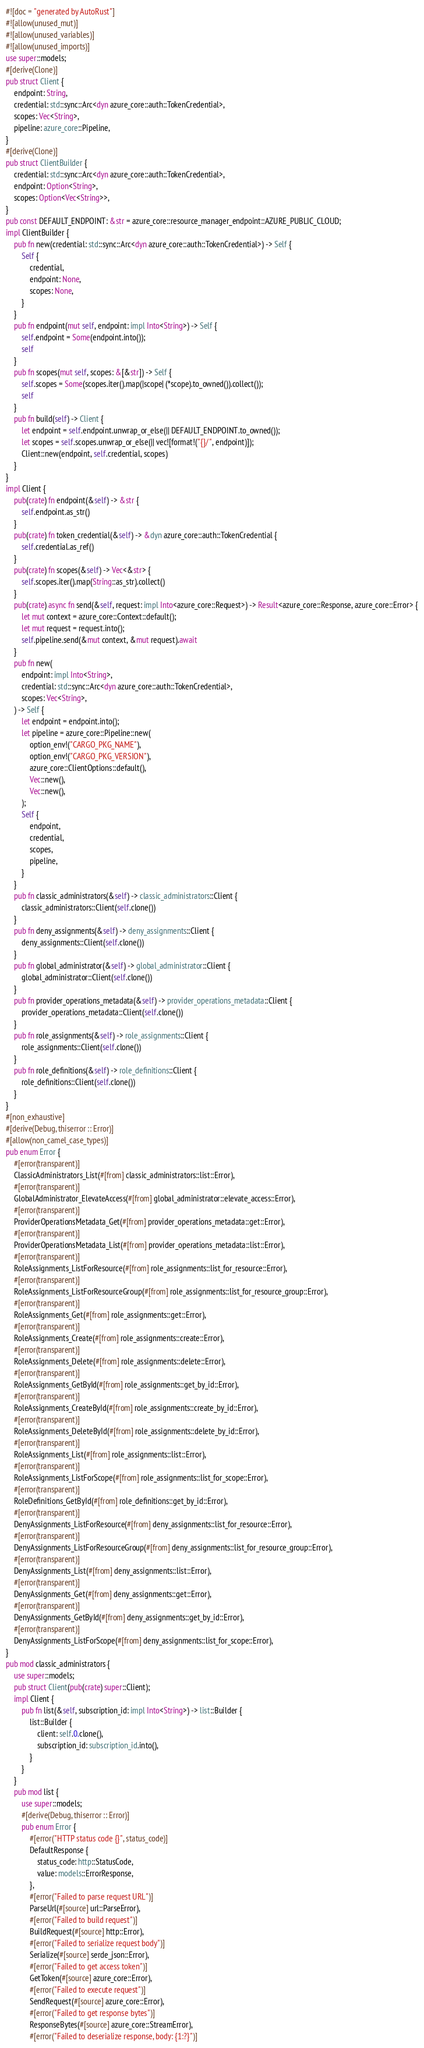<code> <loc_0><loc_0><loc_500><loc_500><_Rust_>#![doc = "generated by AutoRust"]
#![allow(unused_mut)]
#![allow(unused_variables)]
#![allow(unused_imports)]
use super::models;
#[derive(Clone)]
pub struct Client {
    endpoint: String,
    credential: std::sync::Arc<dyn azure_core::auth::TokenCredential>,
    scopes: Vec<String>,
    pipeline: azure_core::Pipeline,
}
#[derive(Clone)]
pub struct ClientBuilder {
    credential: std::sync::Arc<dyn azure_core::auth::TokenCredential>,
    endpoint: Option<String>,
    scopes: Option<Vec<String>>,
}
pub const DEFAULT_ENDPOINT: &str = azure_core::resource_manager_endpoint::AZURE_PUBLIC_CLOUD;
impl ClientBuilder {
    pub fn new(credential: std::sync::Arc<dyn azure_core::auth::TokenCredential>) -> Self {
        Self {
            credential,
            endpoint: None,
            scopes: None,
        }
    }
    pub fn endpoint(mut self, endpoint: impl Into<String>) -> Self {
        self.endpoint = Some(endpoint.into());
        self
    }
    pub fn scopes(mut self, scopes: &[&str]) -> Self {
        self.scopes = Some(scopes.iter().map(|scope| (*scope).to_owned()).collect());
        self
    }
    pub fn build(self) -> Client {
        let endpoint = self.endpoint.unwrap_or_else(|| DEFAULT_ENDPOINT.to_owned());
        let scopes = self.scopes.unwrap_or_else(|| vec![format!("{}/", endpoint)]);
        Client::new(endpoint, self.credential, scopes)
    }
}
impl Client {
    pub(crate) fn endpoint(&self) -> &str {
        self.endpoint.as_str()
    }
    pub(crate) fn token_credential(&self) -> &dyn azure_core::auth::TokenCredential {
        self.credential.as_ref()
    }
    pub(crate) fn scopes(&self) -> Vec<&str> {
        self.scopes.iter().map(String::as_str).collect()
    }
    pub(crate) async fn send(&self, request: impl Into<azure_core::Request>) -> Result<azure_core::Response, azure_core::Error> {
        let mut context = azure_core::Context::default();
        let mut request = request.into();
        self.pipeline.send(&mut context, &mut request).await
    }
    pub fn new(
        endpoint: impl Into<String>,
        credential: std::sync::Arc<dyn azure_core::auth::TokenCredential>,
        scopes: Vec<String>,
    ) -> Self {
        let endpoint = endpoint.into();
        let pipeline = azure_core::Pipeline::new(
            option_env!("CARGO_PKG_NAME"),
            option_env!("CARGO_PKG_VERSION"),
            azure_core::ClientOptions::default(),
            Vec::new(),
            Vec::new(),
        );
        Self {
            endpoint,
            credential,
            scopes,
            pipeline,
        }
    }
    pub fn classic_administrators(&self) -> classic_administrators::Client {
        classic_administrators::Client(self.clone())
    }
    pub fn deny_assignments(&self) -> deny_assignments::Client {
        deny_assignments::Client(self.clone())
    }
    pub fn global_administrator(&self) -> global_administrator::Client {
        global_administrator::Client(self.clone())
    }
    pub fn provider_operations_metadata(&self) -> provider_operations_metadata::Client {
        provider_operations_metadata::Client(self.clone())
    }
    pub fn role_assignments(&self) -> role_assignments::Client {
        role_assignments::Client(self.clone())
    }
    pub fn role_definitions(&self) -> role_definitions::Client {
        role_definitions::Client(self.clone())
    }
}
#[non_exhaustive]
#[derive(Debug, thiserror :: Error)]
#[allow(non_camel_case_types)]
pub enum Error {
    #[error(transparent)]
    ClassicAdministrators_List(#[from] classic_administrators::list::Error),
    #[error(transparent)]
    GlobalAdministrator_ElevateAccess(#[from] global_administrator::elevate_access::Error),
    #[error(transparent)]
    ProviderOperationsMetadata_Get(#[from] provider_operations_metadata::get::Error),
    #[error(transparent)]
    ProviderOperationsMetadata_List(#[from] provider_operations_metadata::list::Error),
    #[error(transparent)]
    RoleAssignments_ListForResource(#[from] role_assignments::list_for_resource::Error),
    #[error(transparent)]
    RoleAssignments_ListForResourceGroup(#[from] role_assignments::list_for_resource_group::Error),
    #[error(transparent)]
    RoleAssignments_Get(#[from] role_assignments::get::Error),
    #[error(transparent)]
    RoleAssignments_Create(#[from] role_assignments::create::Error),
    #[error(transparent)]
    RoleAssignments_Delete(#[from] role_assignments::delete::Error),
    #[error(transparent)]
    RoleAssignments_GetById(#[from] role_assignments::get_by_id::Error),
    #[error(transparent)]
    RoleAssignments_CreateById(#[from] role_assignments::create_by_id::Error),
    #[error(transparent)]
    RoleAssignments_DeleteById(#[from] role_assignments::delete_by_id::Error),
    #[error(transparent)]
    RoleAssignments_List(#[from] role_assignments::list::Error),
    #[error(transparent)]
    RoleAssignments_ListForScope(#[from] role_assignments::list_for_scope::Error),
    #[error(transparent)]
    RoleDefinitions_GetById(#[from] role_definitions::get_by_id::Error),
    #[error(transparent)]
    DenyAssignments_ListForResource(#[from] deny_assignments::list_for_resource::Error),
    #[error(transparent)]
    DenyAssignments_ListForResourceGroup(#[from] deny_assignments::list_for_resource_group::Error),
    #[error(transparent)]
    DenyAssignments_List(#[from] deny_assignments::list::Error),
    #[error(transparent)]
    DenyAssignments_Get(#[from] deny_assignments::get::Error),
    #[error(transparent)]
    DenyAssignments_GetById(#[from] deny_assignments::get_by_id::Error),
    #[error(transparent)]
    DenyAssignments_ListForScope(#[from] deny_assignments::list_for_scope::Error),
}
pub mod classic_administrators {
    use super::models;
    pub struct Client(pub(crate) super::Client);
    impl Client {
        pub fn list(&self, subscription_id: impl Into<String>) -> list::Builder {
            list::Builder {
                client: self.0.clone(),
                subscription_id: subscription_id.into(),
            }
        }
    }
    pub mod list {
        use super::models;
        #[derive(Debug, thiserror :: Error)]
        pub enum Error {
            #[error("HTTP status code {}", status_code)]
            DefaultResponse {
                status_code: http::StatusCode,
                value: models::ErrorResponse,
            },
            #[error("Failed to parse request URL")]
            ParseUrl(#[source] url::ParseError),
            #[error("Failed to build request")]
            BuildRequest(#[source] http::Error),
            #[error("Failed to serialize request body")]
            Serialize(#[source] serde_json::Error),
            #[error("Failed to get access token")]
            GetToken(#[source] azure_core::Error),
            #[error("Failed to execute request")]
            SendRequest(#[source] azure_core::Error),
            #[error("Failed to get response bytes")]
            ResponseBytes(#[source] azure_core::StreamError),
            #[error("Failed to deserialize response, body: {1:?}")]</code> 